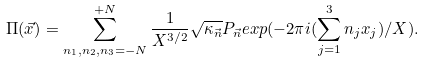Convert formula to latex. <formula><loc_0><loc_0><loc_500><loc_500>\Pi ( \vec { x } ) = \sum _ { n _ { 1 } , n _ { 2 } , n _ { 3 } = - N } ^ { + N } \frac { 1 } { X ^ { 3 / 2 } } \sqrt { \kappa _ { \vec { n } } } P _ { \vec { n } } e x p ( - 2 \pi i ( \sum _ { j = 1 } ^ { 3 } n _ { j } x _ { j } ) / X ) .</formula> 